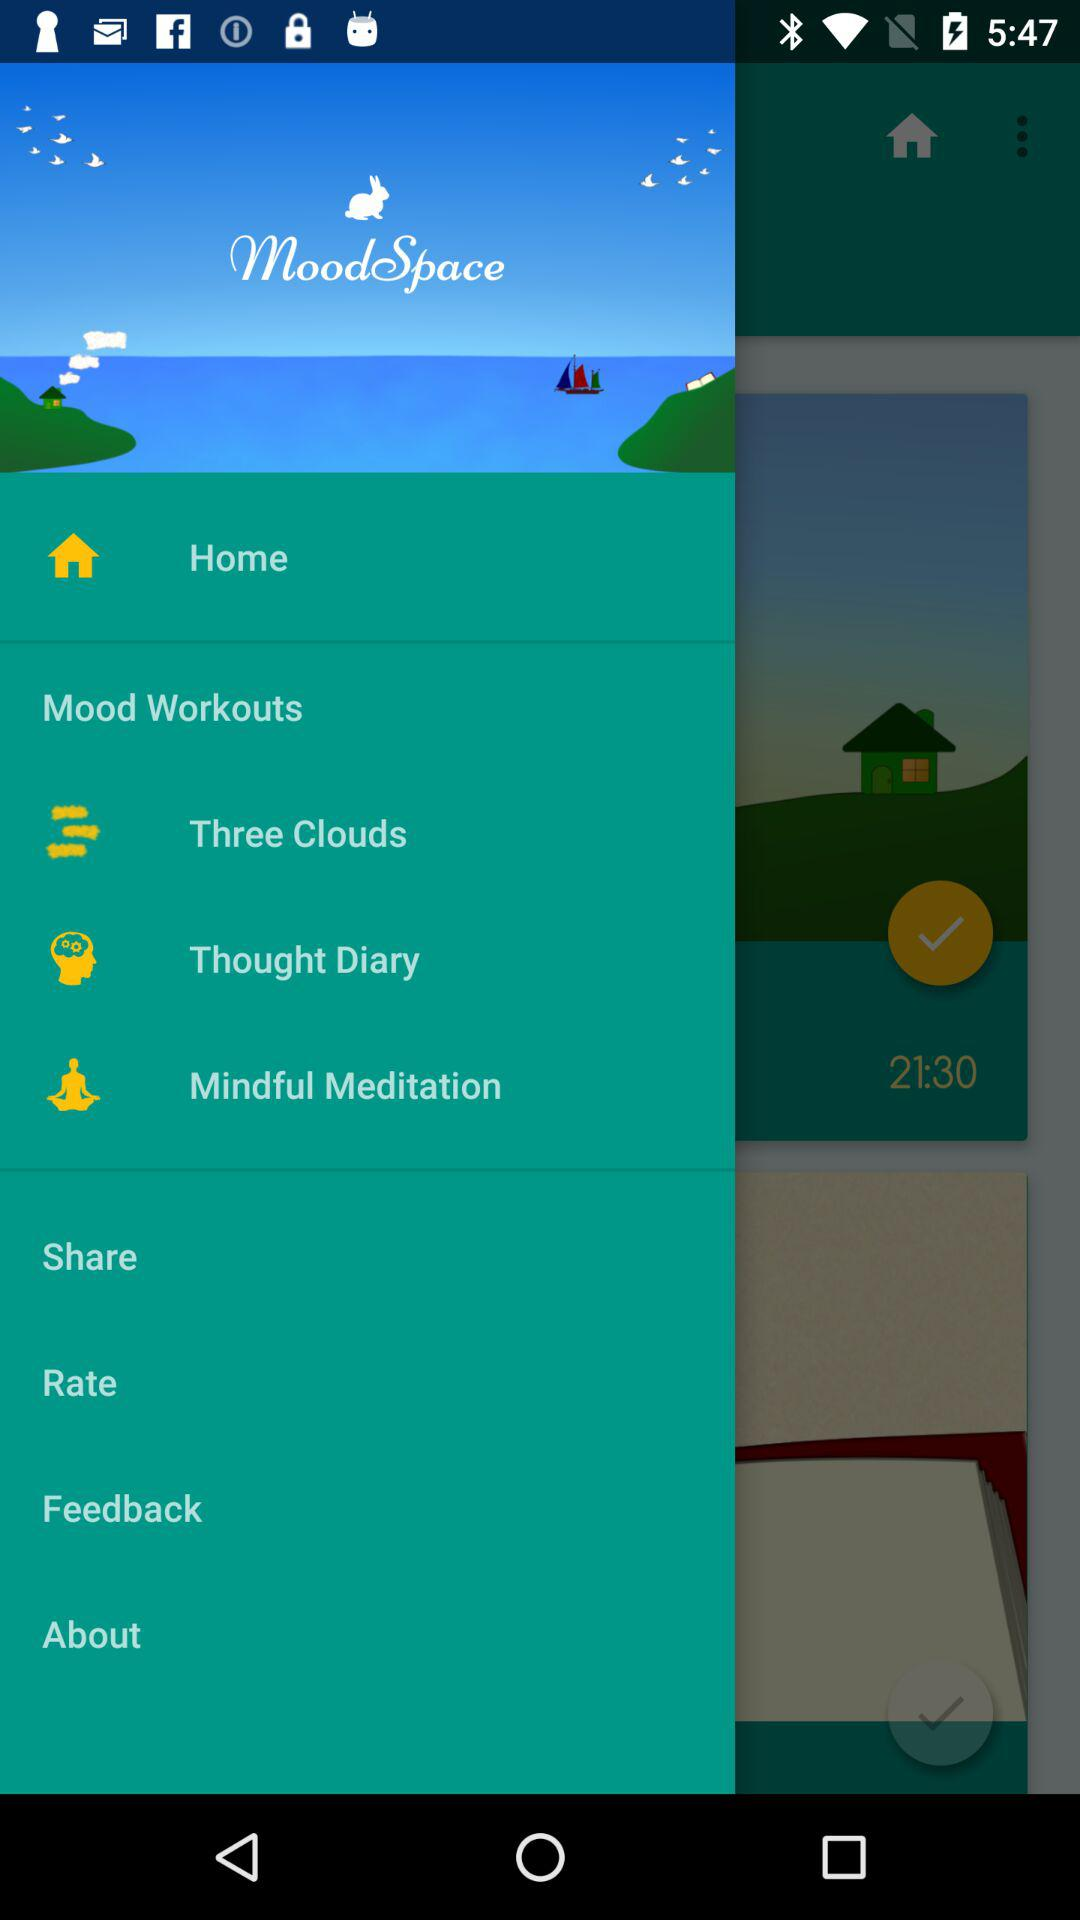What is the name of the application? The name of the application is "moodSpace". 